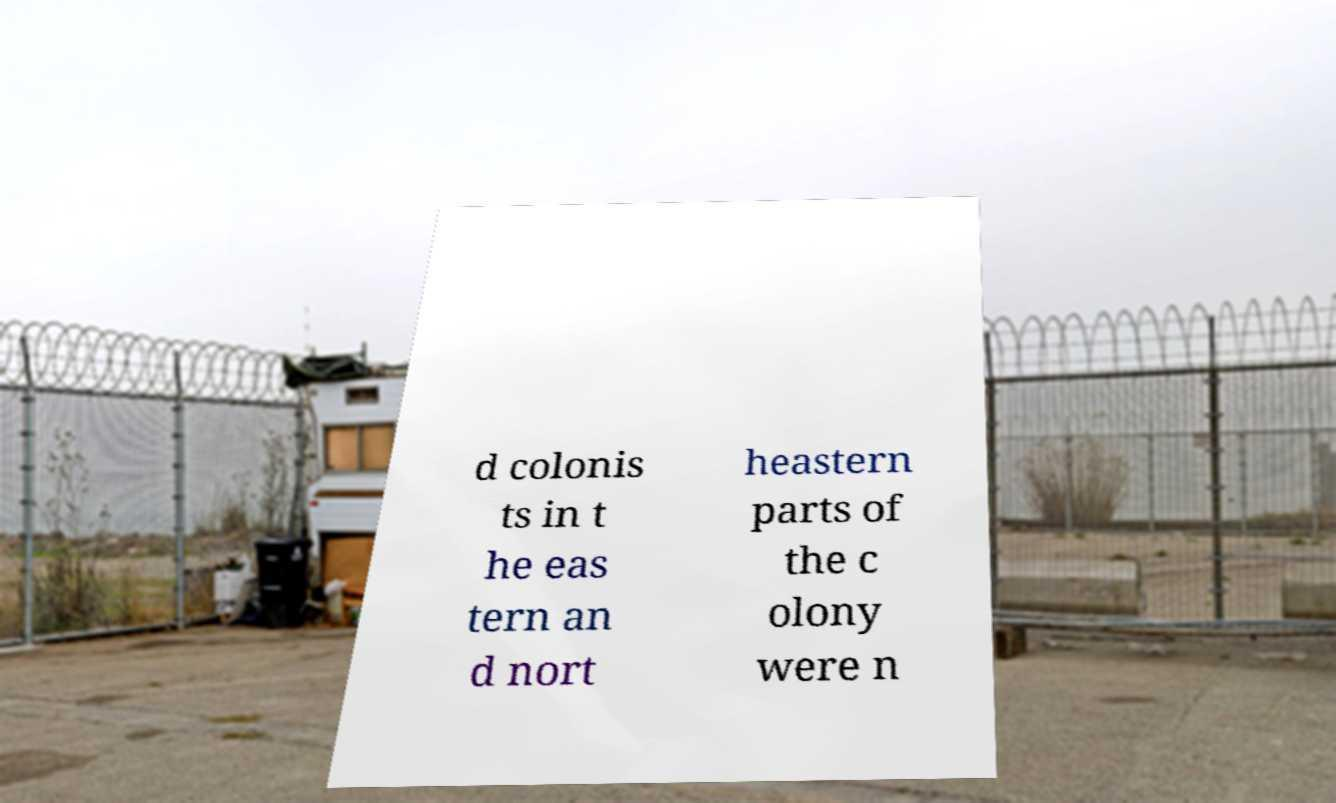Could you assist in decoding the text presented in this image and type it out clearly? d colonis ts in t he eas tern an d nort heastern parts of the c olony were n 